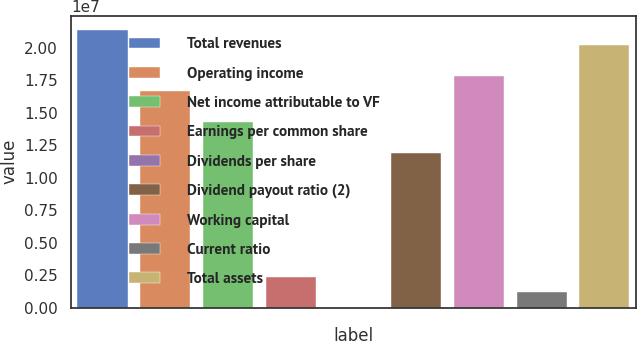Convert chart. <chart><loc_0><loc_0><loc_500><loc_500><bar_chart><fcel>Total revenues<fcel>Operating income<fcel>Net income attributable to VF<fcel>Earnings per common share<fcel>Dividends per share<fcel>Dividend payout ratio (2)<fcel>Working capital<fcel>Current ratio<fcel>Total assets<nl><fcel>2.13871e+07<fcel>1.66344e+07<fcel>1.42581e+07<fcel>2.37635e+06<fcel>1.11<fcel>1.18817e+07<fcel>1.78226e+07<fcel>1.18817e+06<fcel>2.01989e+07<nl></chart> 